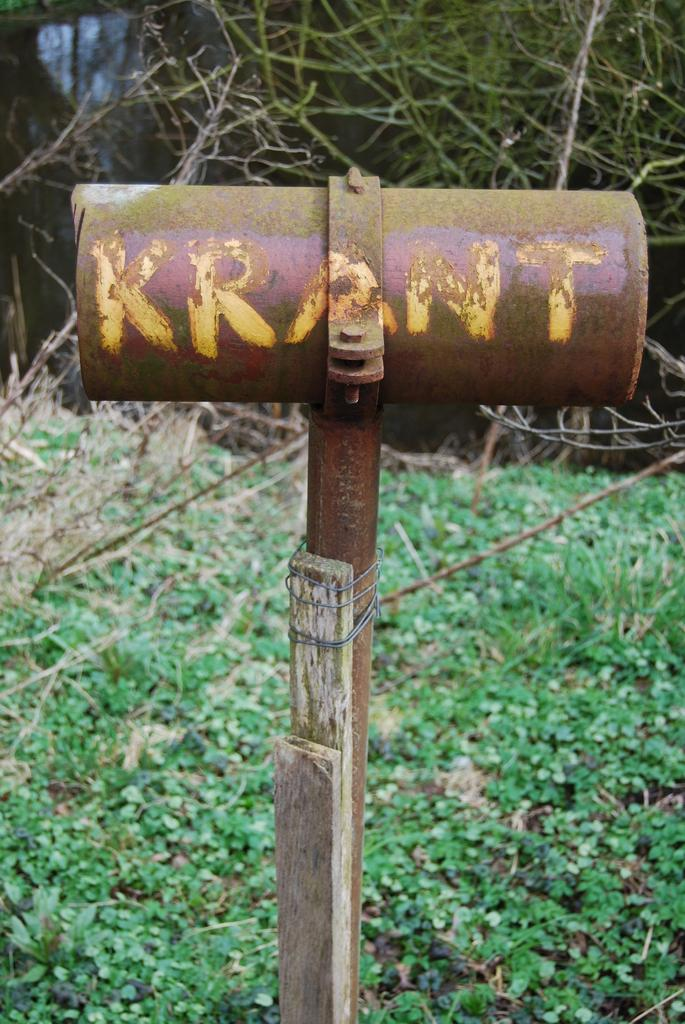What tool is visible in the image? There is a hammer in the image. What type of surface is on the ground in the image? There is grass on the ground in the image. What can be seen in the background of the image? There are plants in the background of the image. What type of current can be seen flowing through the hammer in the image? There is no current flowing through the hammer in the image; it is a hammer is a tool and not an electrical component. 